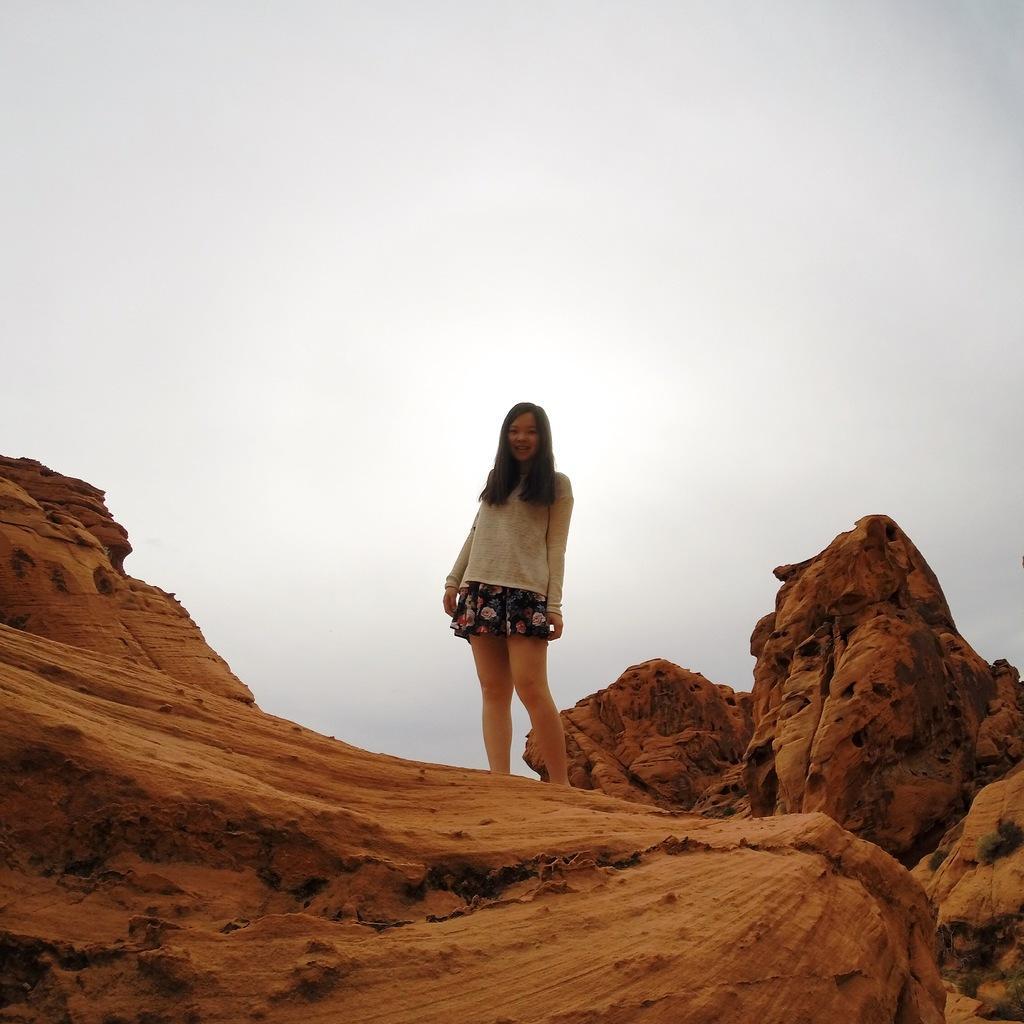Describe this image in one or two sentences. In this image I can see a girl standing on red dune. 